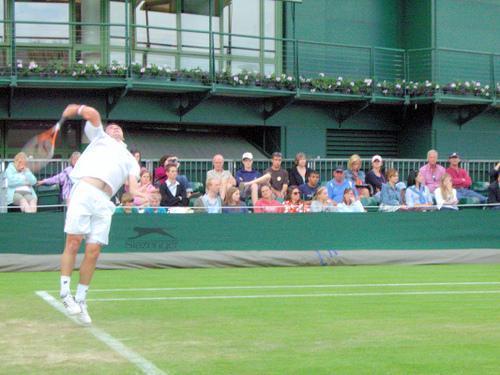How many people are there?
Give a very brief answer. 2. How many black cat are this image?
Give a very brief answer. 0. 